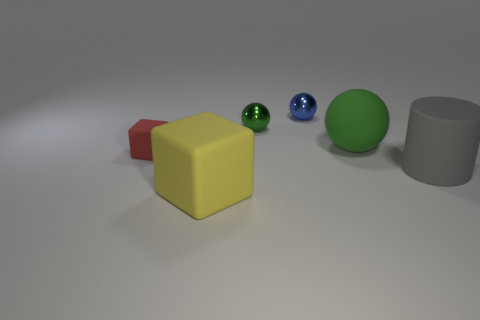Imagine these objects are part of a game, what could be the rules based on their arrangement? Envisioning a game involving these objects, the rule could be to arrange them by size or color. Alternatively, the spheres could represent different point values, and the cube could be a 'dice' that determines how many spaces a player can move the spheres on a hypothetical game board outlined by the shadows. 